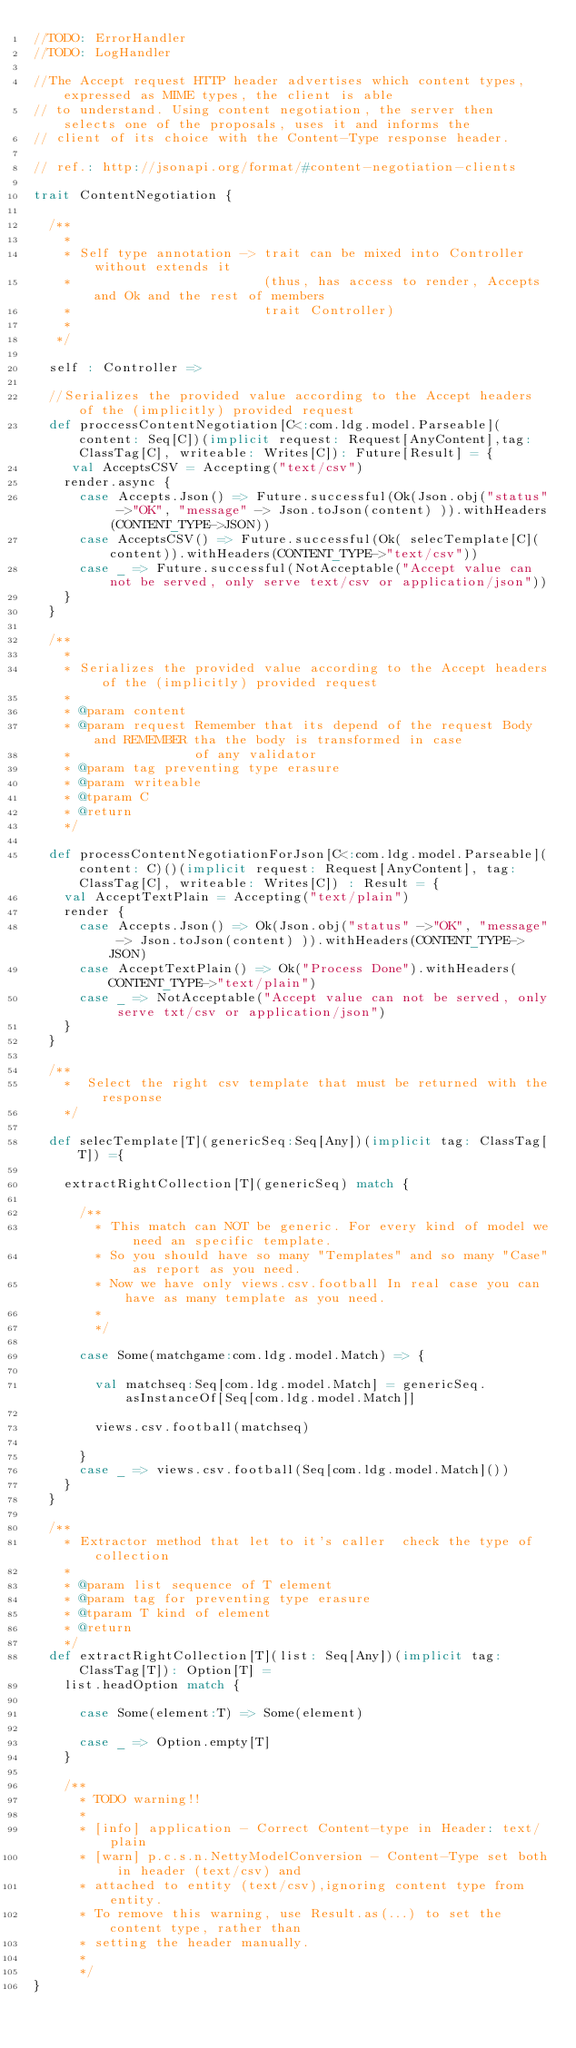<code> <loc_0><loc_0><loc_500><loc_500><_Scala_>//TODO: ErrorHandler
//TODO: LogHandler

//The Accept request HTTP header advertises which content types, expressed as MIME types, the client is able
// to understand. Using content negotiation, the server then selects one of the proposals, uses it and informs the
// client of its choice with the Content-Type response header.

// ref.: http://jsonapi.org/format/#content-negotiation-clients

trait ContentNegotiation {

  /**
    *
    * Self type annotation -> trait can be mixed into Controller without extends it
    *                         (thus, has access to render, Accepts and Ok and the rest of members
    *                         trait Controller)
    *
   */

  self : Controller =>

  //Serializes the provided value according to the Accept headers of the (implicitly) provided request
  def proccessContentNegotiation[C<:com.ldg.model.Parseable](content: Seq[C])(implicit request: Request[AnyContent],tag: ClassTag[C], writeable: Writes[C]): Future[Result] = {
     val AcceptsCSV = Accepting("text/csv")
    render.async {
      case Accepts.Json() => Future.successful(Ok(Json.obj("status" ->"OK", "message" -> Json.toJson(content) )).withHeaders(CONTENT_TYPE->JSON))
      case AcceptsCSV() => Future.successful(Ok( selecTemplate[C](content)).withHeaders(CONTENT_TYPE->"text/csv"))
      case _ => Future.successful(NotAcceptable("Accept value can not be served, only serve text/csv or application/json"))
    }
  }

  /**
    *
    * Serializes the provided value according to the Accept headers of the (implicitly) provided request
    *
    * @param content
    * @param request Remember that its depend of the request Body and REMEMBER tha the body is transformed in case
    *                of any validator
    * @param tag preventing type erasure
    * @param writeable
    * @tparam C
    * @return
    */

  def processContentNegotiationForJson[C<:com.ldg.model.Parseable](content: C)()(implicit request: Request[AnyContent], tag: ClassTag[C], writeable: Writes[C]) : Result = {
    val AcceptTextPlain = Accepting("text/plain")
    render {
      case Accepts.Json() => Ok(Json.obj("status" ->"OK", "message" -> Json.toJson(content) )).withHeaders(CONTENT_TYPE->JSON)
      case AcceptTextPlain() => Ok("Process Done").withHeaders(CONTENT_TYPE->"text/plain")
      case _ => NotAcceptable("Accept value can not be served, only serve txt/csv or application/json")
    }
  }

  /**
    *  Select the right csv template that must be returned with the response
    */

  def selecTemplate[T](genericSeq:Seq[Any])(implicit tag: ClassTag[T]) ={

    extractRightCollection[T](genericSeq) match {

      /**
        * This match can NOT be generic. For every kind of model we need an specific template.
        * So you should have so many "Templates" and so many "Case" as report as you need.
        * Now we have only views.csv.football In real case you can have as many template as you need.
        *
        */

      case Some(matchgame:com.ldg.model.Match) => {

        val matchseq:Seq[com.ldg.model.Match] = genericSeq.asInstanceOf[Seq[com.ldg.model.Match]]

        views.csv.football(matchseq)

      }
      case _ => views.csv.football(Seq[com.ldg.model.Match]())
    }
  }

  /**
    * Extractor method that let to it's caller  check the type of collection
    *
    * @param list sequence of T element
    * @param tag for preventing type erasure
    * @tparam T kind of element
    * @return
    */
  def extractRightCollection[T](list: Seq[Any])(implicit tag: ClassTag[T]): Option[T] =
    list.headOption match {

      case Some(element:T) => Some(element)

      case _ => Option.empty[T]
    }

    /**
      * TODO warning!!
      *
      * [info] application - Correct Content-type in Header: text/plain
      * [warn] p.c.s.n.NettyModelConversion - Content-Type set both in header (text/csv) and
      * attached to entity (text/csv),ignoring content type from entity.
      * To remove this warning, use Result.as(...) to set the content type, rather than
      * setting the header manually.
      *
      */
}</code> 